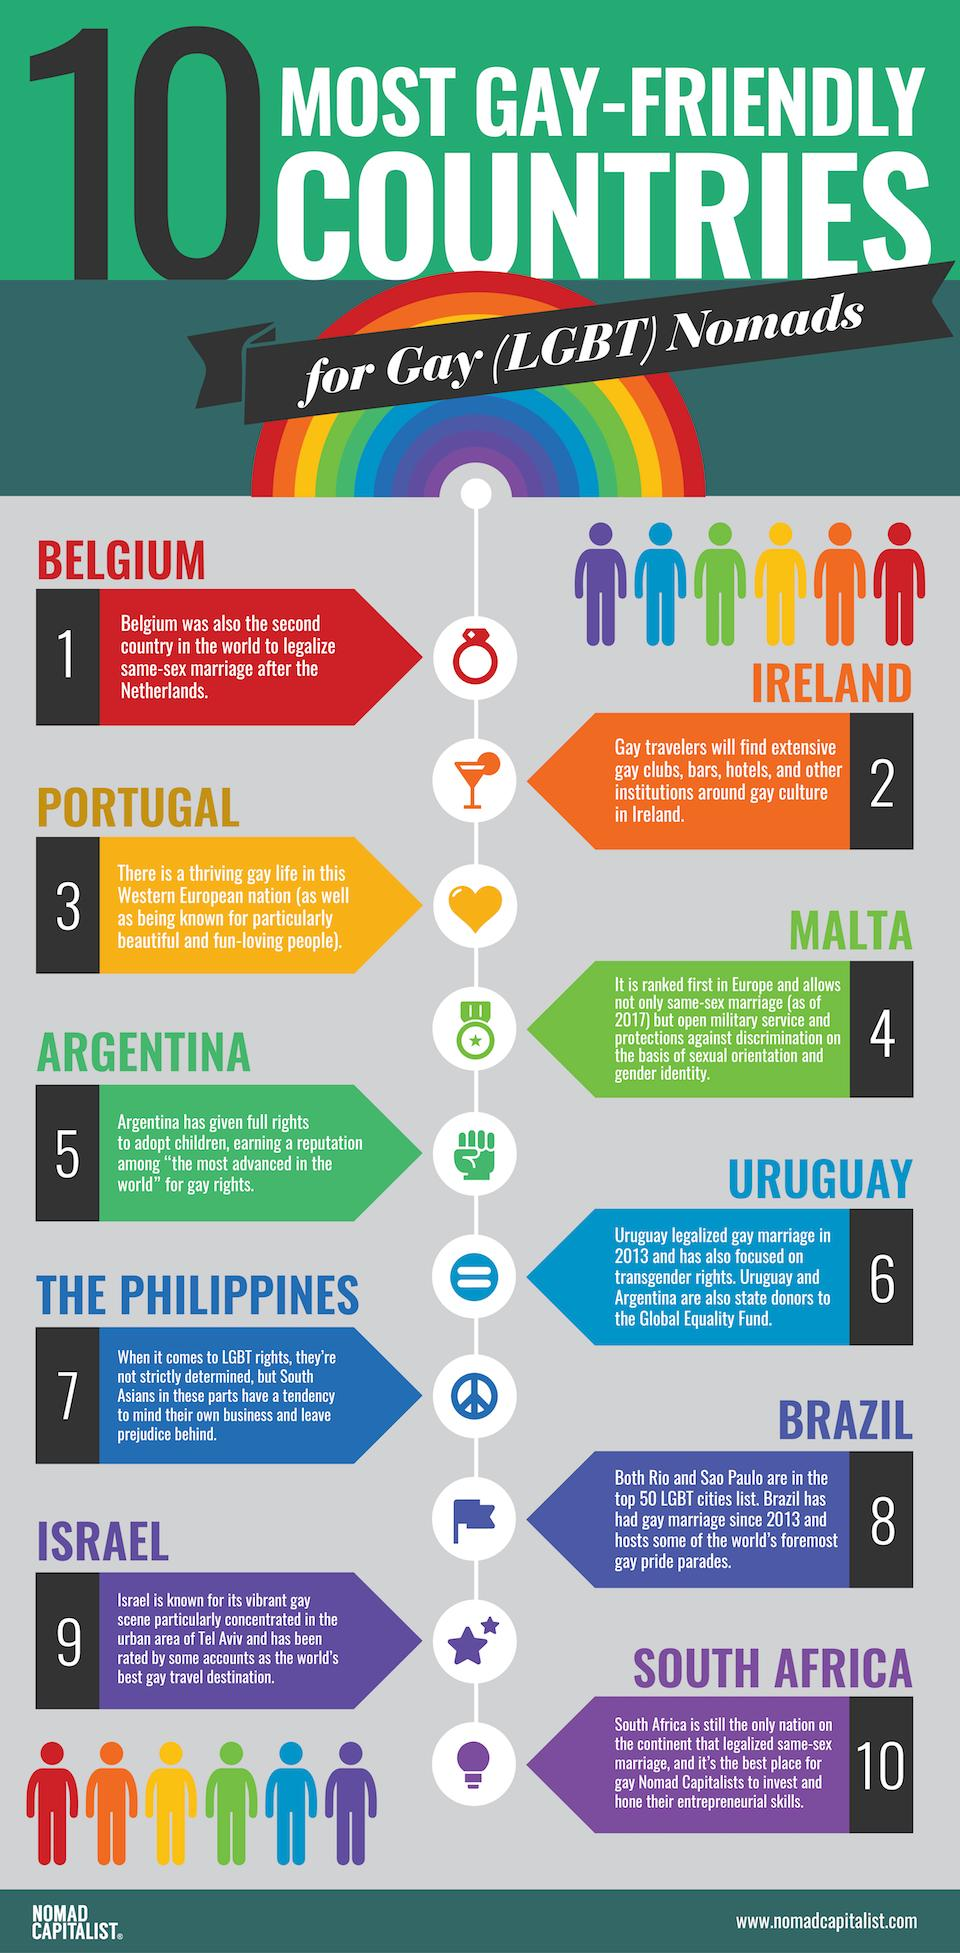Mention a couple of crucial points in this snapshot. According to a rating, Israel is recognized as the top gay travel destination in the world. Brazil is the country that hosts the world's most prominent gay pride parades. It is my opinion that South Africa is the best location for gay Nomad Capitalists to invest and hone their entrepreneurial skills. Belgium is the second country in the world to legalize same-sex marriage after the Netherlands. It is widely acknowledged that Portugal is the Western European nation that promotes and maintains a vibrant gay culture, as evidenced by the abundance of gay-friendly businesses, events, and organizations in the country. 